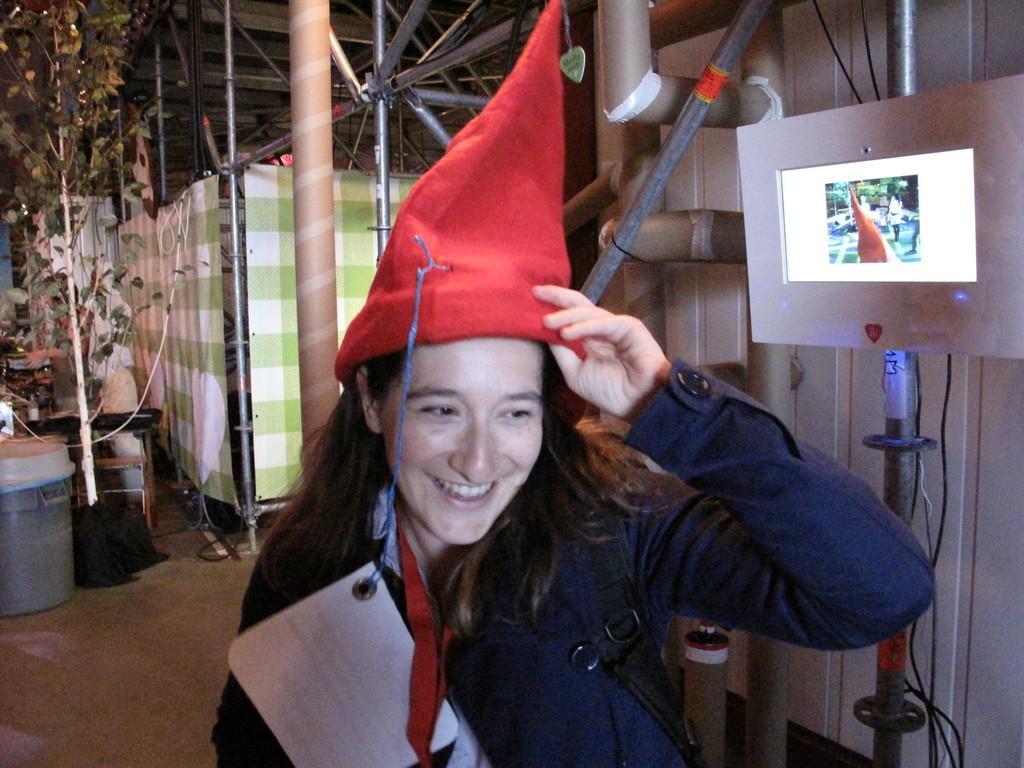Could you give a brief overview of what you see in this image? In this image we can see a woman wearing red cap and smiling. Image also consists of a pole, rod, screen, tubes, trash bin and also a tree. We can also see some rods at the top. Floor is also visible. 